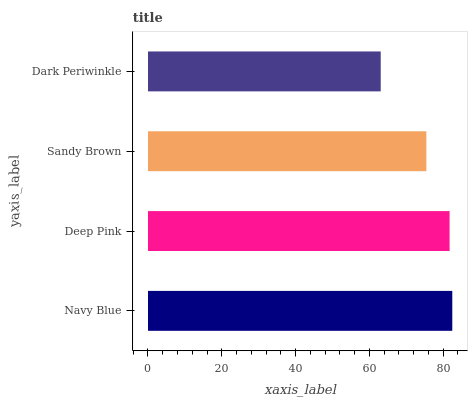Is Dark Periwinkle the minimum?
Answer yes or no. Yes. Is Navy Blue the maximum?
Answer yes or no. Yes. Is Deep Pink the minimum?
Answer yes or no. No. Is Deep Pink the maximum?
Answer yes or no. No. Is Navy Blue greater than Deep Pink?
Answer yes or no. Yes. Is Deep Pink less than Navy Blue?
Answer yes or no. Yes. Is Deep Pink greater than Navy Blue?
Answer yes or no. No. Is Navy Blue less than Deep Pink?
Answer yes or no. No. Is Deep Pink the high median?
Answer yes or no. Yes. Is Sandy Brown the low median?
Answer yes or no. Yes. Is Sandy Brown the high median?
Answer yes or no. No. Is Deep Pink the low median?
Answer yes or no. No. 